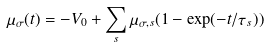<formula> <loc_0><loc_0><loc_500><loc_500>\mu _ { \sigma } ( t ) = - V _ { 0 } + \sum _ { s } \mu _ { \sigma , s } ( 1 - \exp ( - t / \tau _ { s } ) )</formula> 